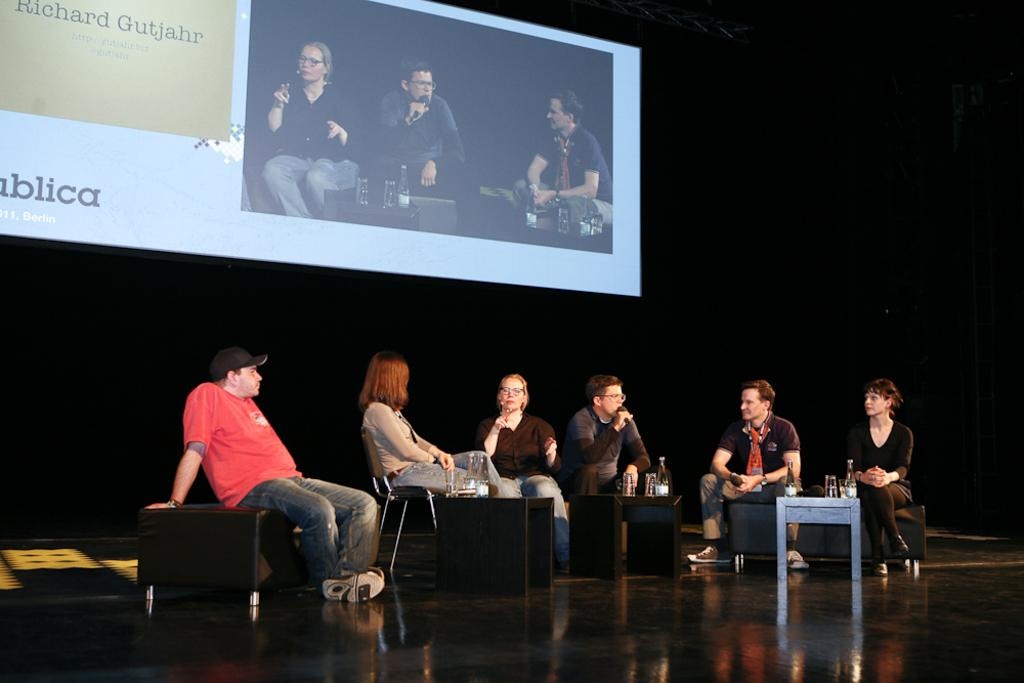How many people are present in the image? There are six persons in the image. What are the persons doing in the image? The persons are sitting on a sofa and chairs. Are any of the persons engaged in a conversation? Yes, two of the persons are talking. What can be seen in the background of the image? There is a projected image in the background. What type of friction is present between the persons in the image? There is no mention of friction between the persons in the image; they are simply sitting and talking. How do the giants in the image interact with the persons? There are no giants present in the image; it only features six persons sitting and talking. 